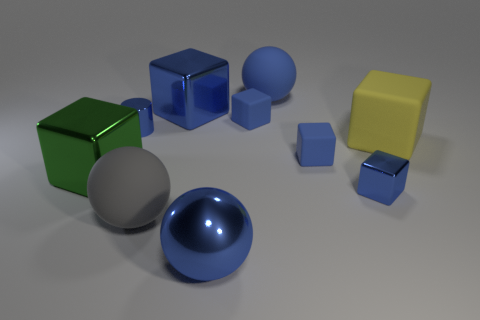Subtract all small rubber cubes. How many cubes are left? 4 Subtract all blue cubes. How many cubes are left? 2 Subtract all spheres. How many objects are left? 7 Subtract 3 cubes. How many cubes are left? 3 Subtract all big blue blocks. Subtract all large gray matte objects. How many objects are left? 8 Add 5 big balls. How many big balls are left? 8 Add 4 blue shiny cylinders. How many blue shiny cylinders exist? 5 Subtract 0 brown balls. How many objects are left? 10 Subtract all purple spheres. Subtract all yellow blocks. How many spheres are left? 3 Subtract all yellow spheres. How many yellow cubes are left? 1 